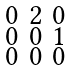Convert formula to latex. <formula><loc_0><loc_0><loc_500><loc_500>\begin{smallmatrix} 0 & 2 & 0 \\ 0 & 0 & 1 \\ 0 & 0 & 0 \end{smallmatrix}</formula> 